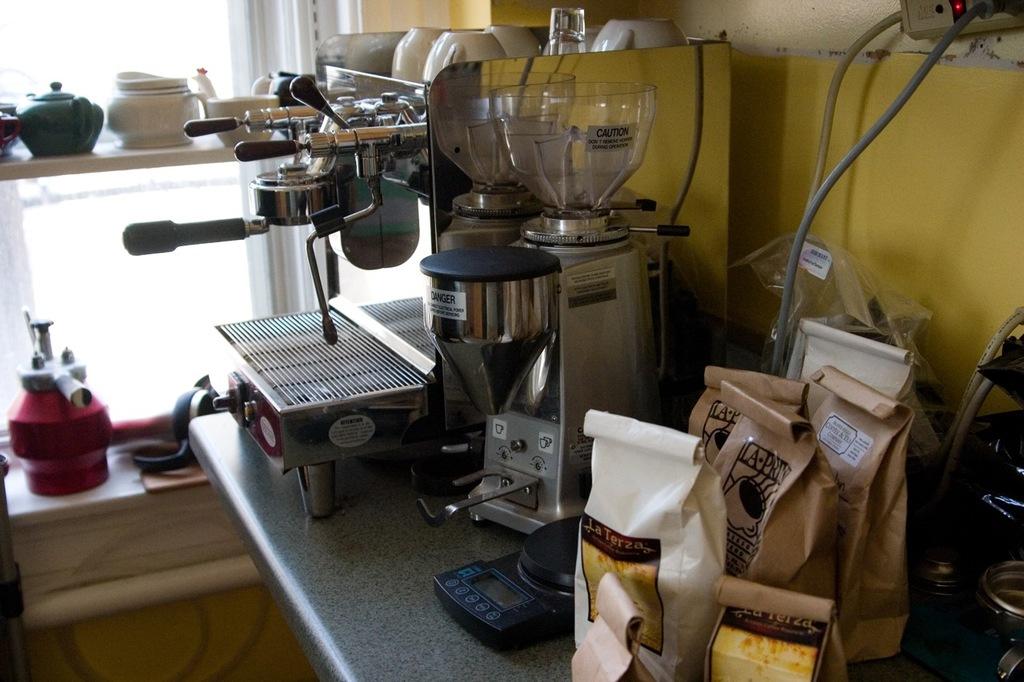What advice is written on the top of the coffee machine?
Your answer should be compact. Danger. 